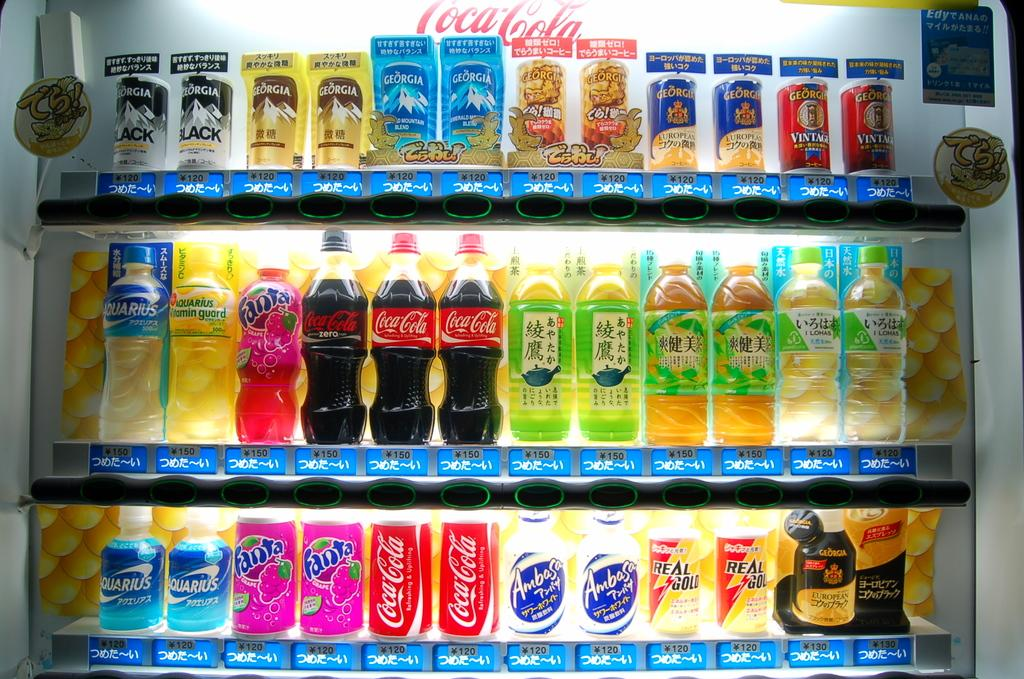Provide a one-sentence caption for the provided image. A fridge display includes a pink bottle of Fanta Grape. 